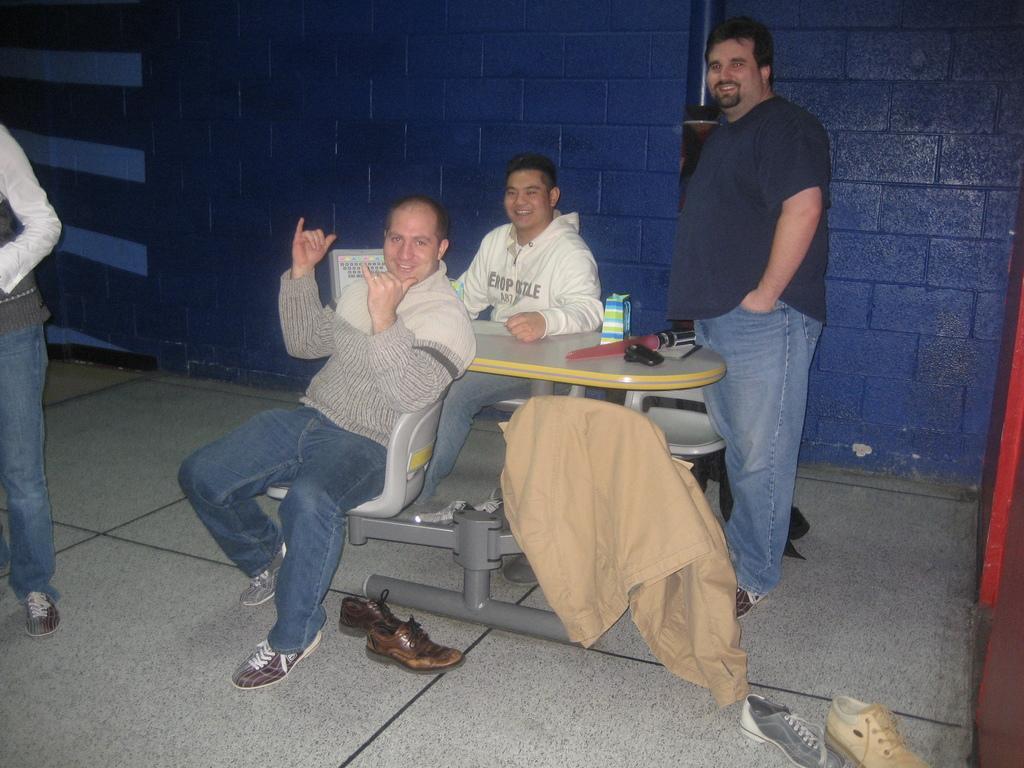In one or two sentences, can you explain what this image depicts? In this picture we can see four persons two are sitting and two are standing, they are smiling and in front of them there is table and on table we can see some items and here on floor we have shoes and in the background we can see blue color wall. 